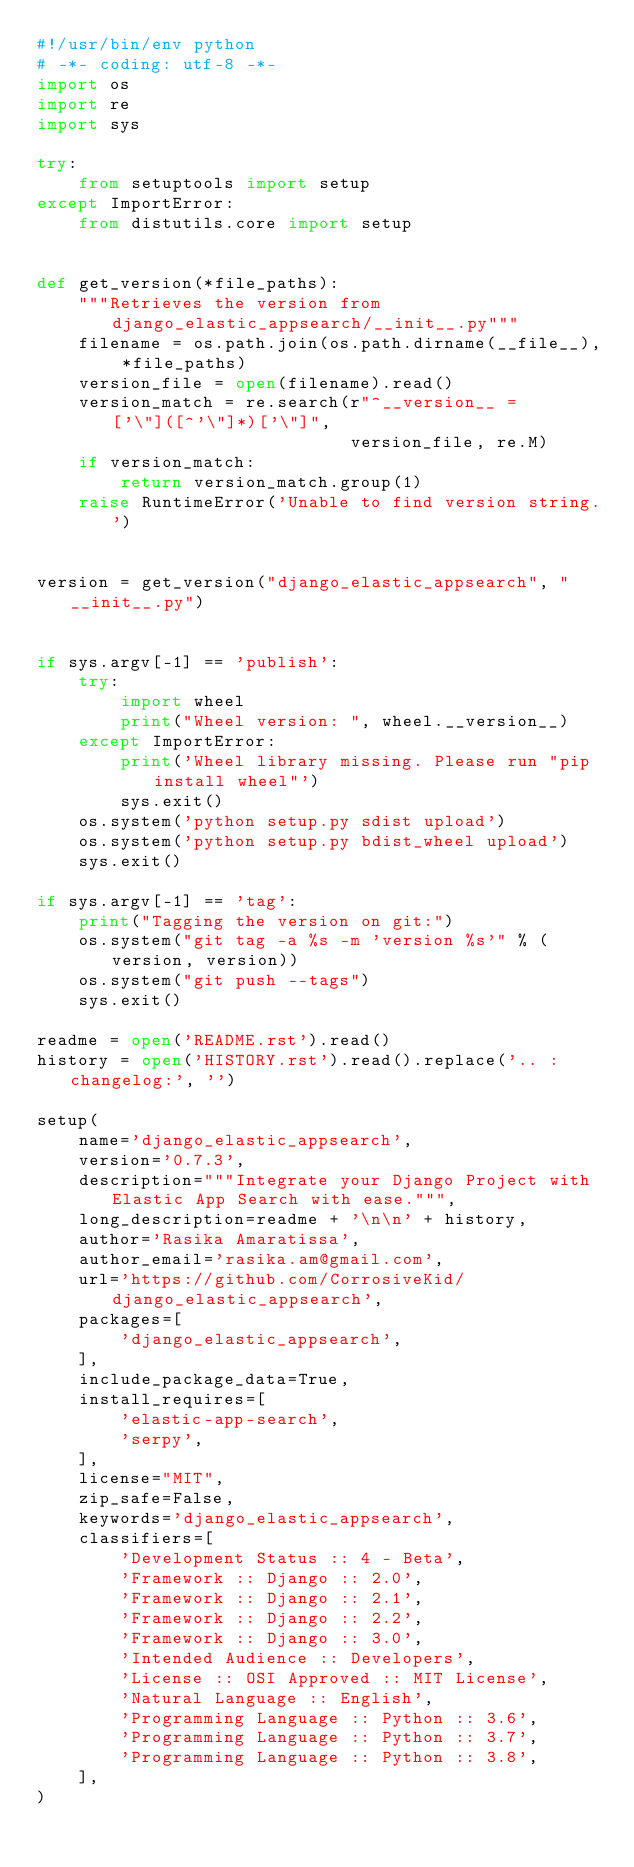Convert code to text. <code><loc_0><loc_0><loc_500><loc_500><_Python_>#!/usr/bin/env python
# -*- coding: utf-8 -*-
import os
import re
import sys

try:
    from setuptools import setup
except ImportError:
    from distutils.core import setup


def get_version(*file_paths):
    """Retrieves the version from django_elastic_appsearch/__init__.py"""
    filename = os.path.join(os.path.dirname(__file__), *file_paths)
    version_file = open(filename).read()
    version_match = re.search(r"^__version__ = ['\"]([^'\"]*)['\"]",
                              version_file, re.M)
    if version_match:
        return version_match.group(1)
    raise RuntimeError('Unable to find version string.')


version = get_version("django_elastic_appsearch", "__init__.py")


if sys.argv[-1] == 'publish':
    try:
        import wheel
        print("Wheel version: ", wheel.__version__)
    except ImportError:
        print('Wheel library missing. Please run "pip install wheel"')
        sys.exit()
    os.system('python setup.py sdist upload')
    os.system('python setup.py bdist_wheel upload')
    sys.exit()

if sys.argv[-1] == 'tag':
    print("Tagging the version on git:")
    os.system("git tag -a %s -m 'version %s'" % (version, version))
    os.system("git push --tags")
    sys.exit()

readme = open('README.rst').read()
history = open('HISTORY.rst').read().replace('.. :changelog:', '')

setup(
    name='django_elastic_appsearch',
    version='0.7.3',
    description="""Integrate your Django Project with Elastic App Search with ease.""",
    long_description=readme + '\n\n' + history,
    author='Rasika Amaratissa',
    author_email='rasika.am@gmail.com',
    url='https://github.com/CorrosiveKid/django_elastic_appsearch',
    packages=[
        'django_elastic_appsearch',
    ],
    include_package_data=True,
    install_requires=[
        'elastic-app-search',
        'serpy',
    ],
    license="MIT",
    zip_safe=False,
    keywords='django_elastic_appsearch',
    classifiers=[
        'Development Status :: 4 - Beta',
        'Framework :: Django :: 2.0',
        'Framework :: Django :: 2.1',
        'Framework :: Django :: 2.2',
        'Framework :: Django :: 3.0',
        'Intended Audience :: Developers',
        'License :: OSI Approved :: MIT License',
        'Natural Language :: English',
        'Programming Language :: Python :: 3.6',
        'Programming Language :: Python :: 3.7',
        'Programming Language :: Python :: 3.8',
    ],
)
</code> 